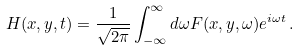Convert formula to latex. <formula><loc_0><loc_0><loc_500><loc_500>H ( x , y , t ) = \frac { 1 } { \sqrt { 2 \pi } } \int _ { - \infty } ^ { \infty } d \omega F ( x , y , \omega ) e ^ { i \omega t } \, .</formula> 